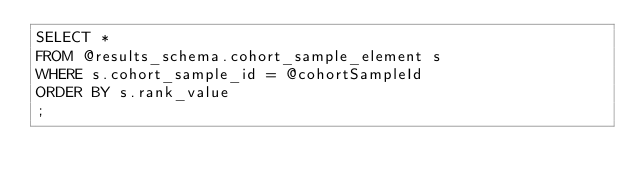Convert code to text. <code><loc_0><loc_0><loc_500><loc_500><_SQL_>SELECT *
FROM @results_schema.cohort_sample_element s
WHERE s.cohort_sample_id = @cohortSampleId
ORDER BY s.rank_value
;</code> 